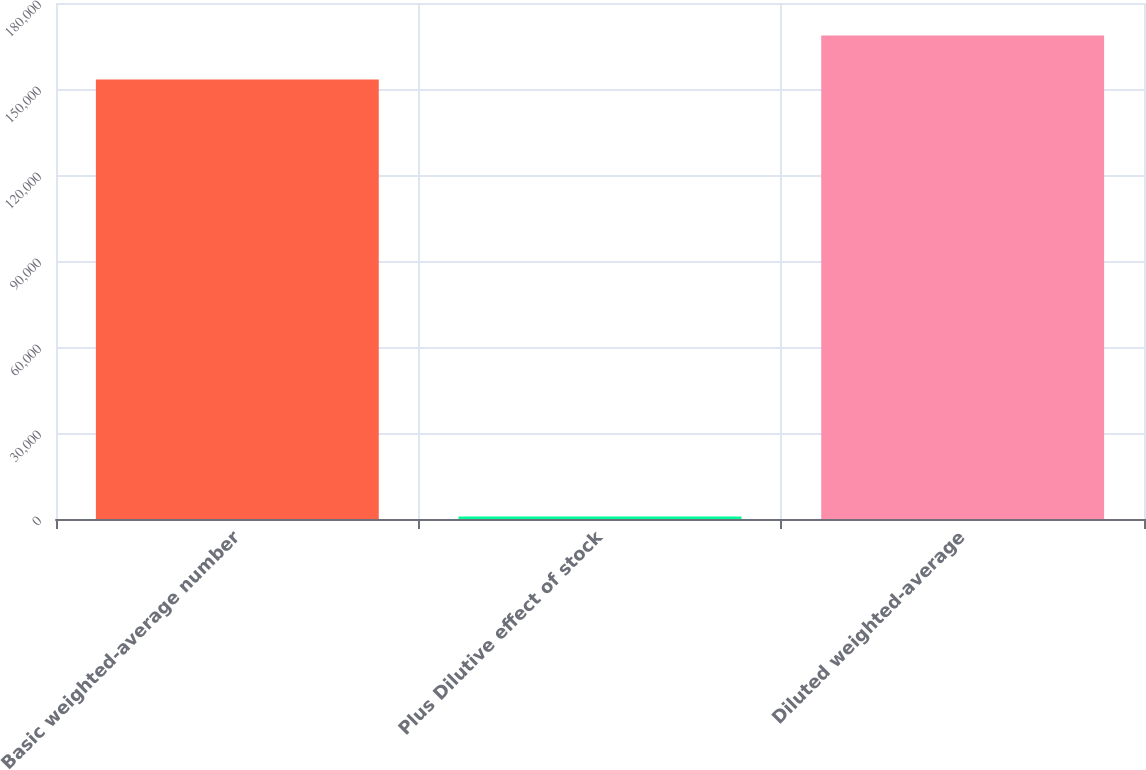Convert chart. <chart><loc_0><loc_0><loc_500><loc_500><bar_chart><fcel>Basic weighted-average number<fcel>Plus Dilutive effect of stock<fcel>Diluted weighted-average<nl><fcel>153342<fcel>889<fcel>168676<nl></chart> 